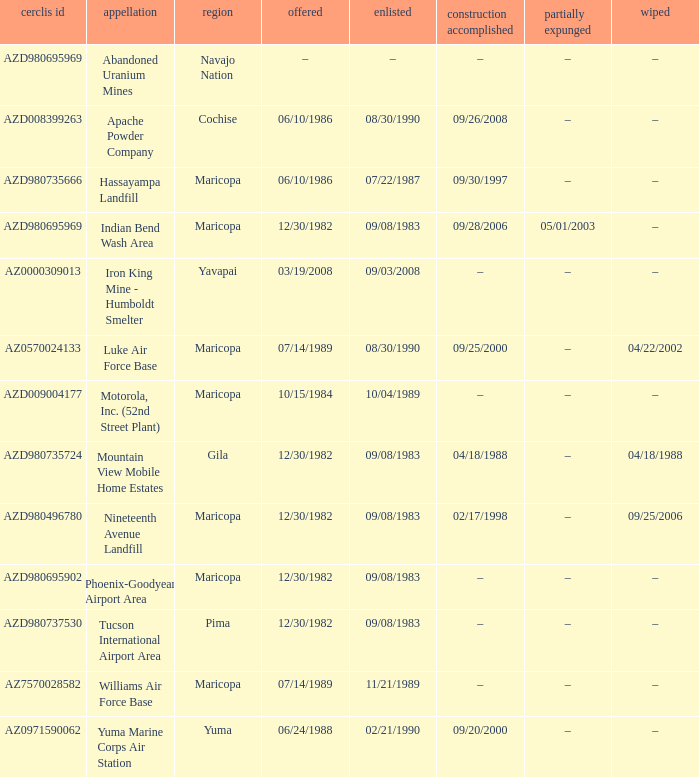When was the site listed when the county is cochise? 08/30/1990. 